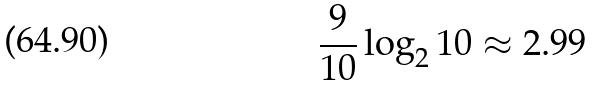<formula> <loc_0><loc_0><loc_500><loc_500>\frac { 9 } { 1 0 } \log _ { 2 } 1 0 \approx 2 . 9 9</formula> 